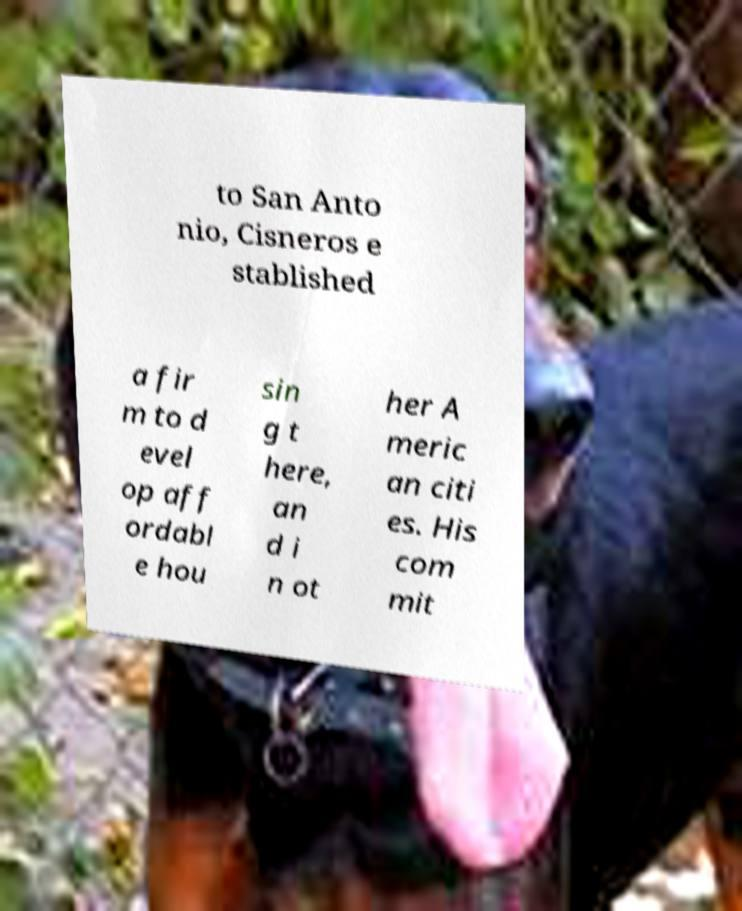Can you accurately transcribe the text from the provided image for me? to San Anto nio, Cisneros e stablished a fir m to d evel op aff ordabl e hou sin g t here, an d i n ot her A meric an citi es. His com mit 